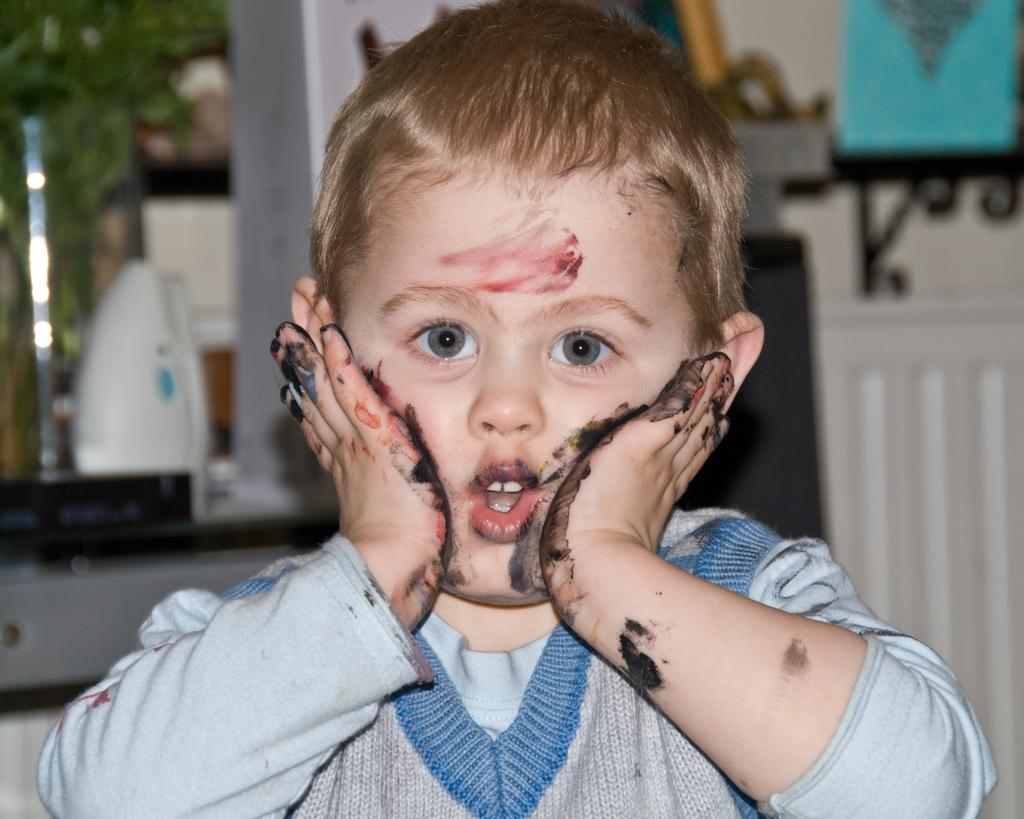What is the main subject of the image? There is a child in the image. What is the child doing with his hands? The child's hands are full of color. How is the child interacting with his face? The child is placing his hands on his cheek. What type of clothing is the child wearing? The child is wearing a sweater. What type of slave is depicted in the image? There is no slave depicted in the image; it features a child with color on his hands and placing them on his cheek. What type of lettuce can be seen in the image? There is no lettuce present in the image. 